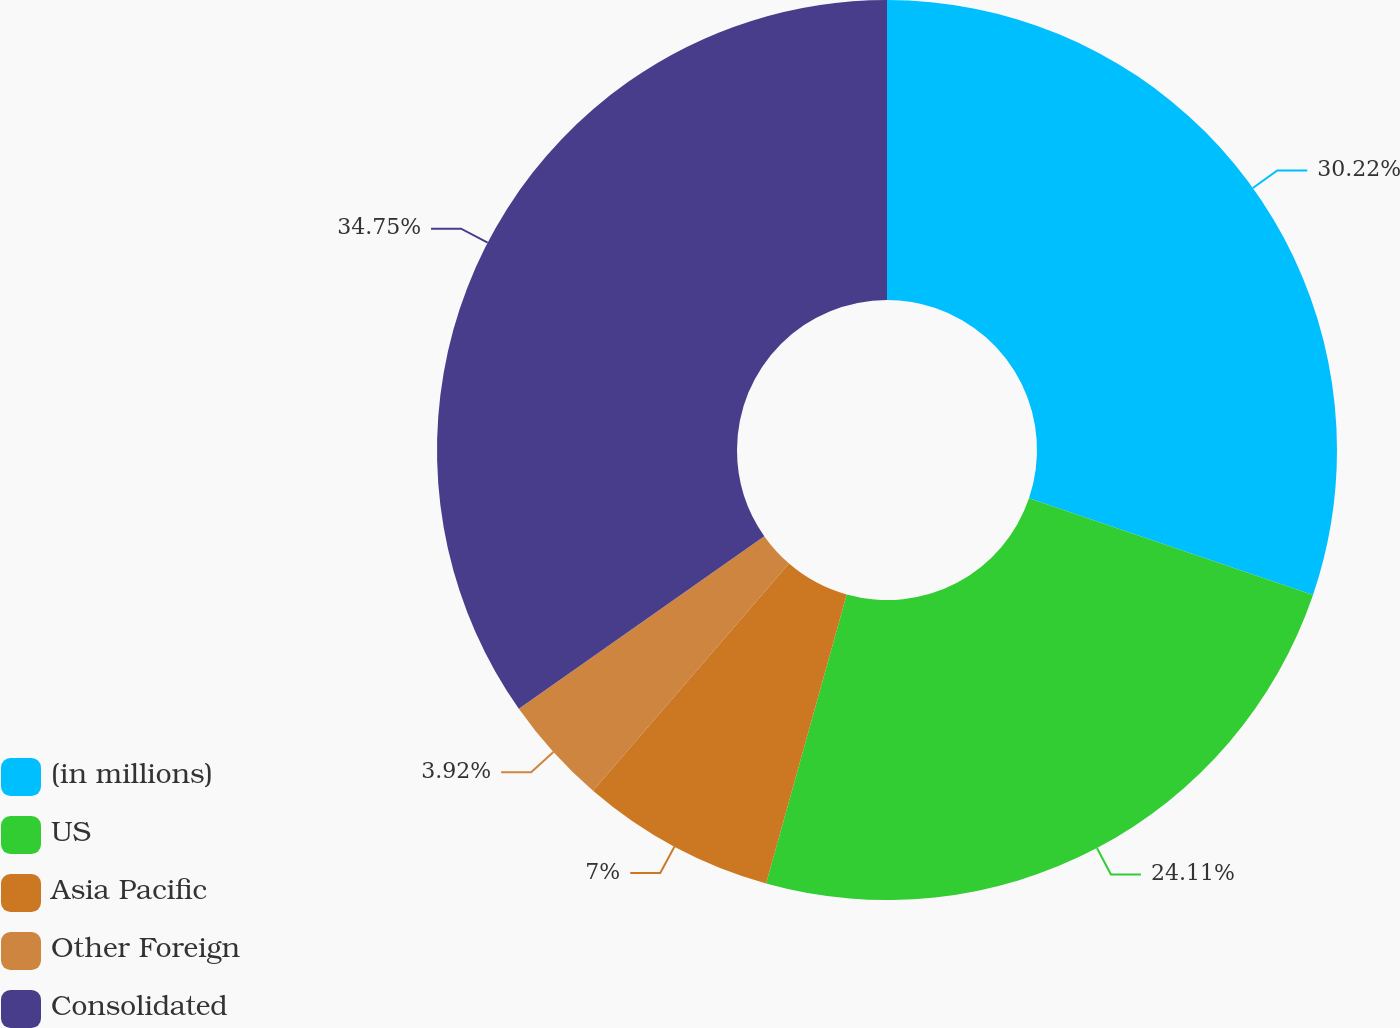<chart> <loc_0><loc_0><loc_500><loc_500><pie_chart><fcel>(in millions)<fcel>US<fcel>Asia Pacific<fcel>Other Foreign<fcel>Consolidated<nl><fcel>30.22%<fcel>24.11%<fcel>7.0%<fcel>3.92%<fcel>34.75%<nl></chart> 